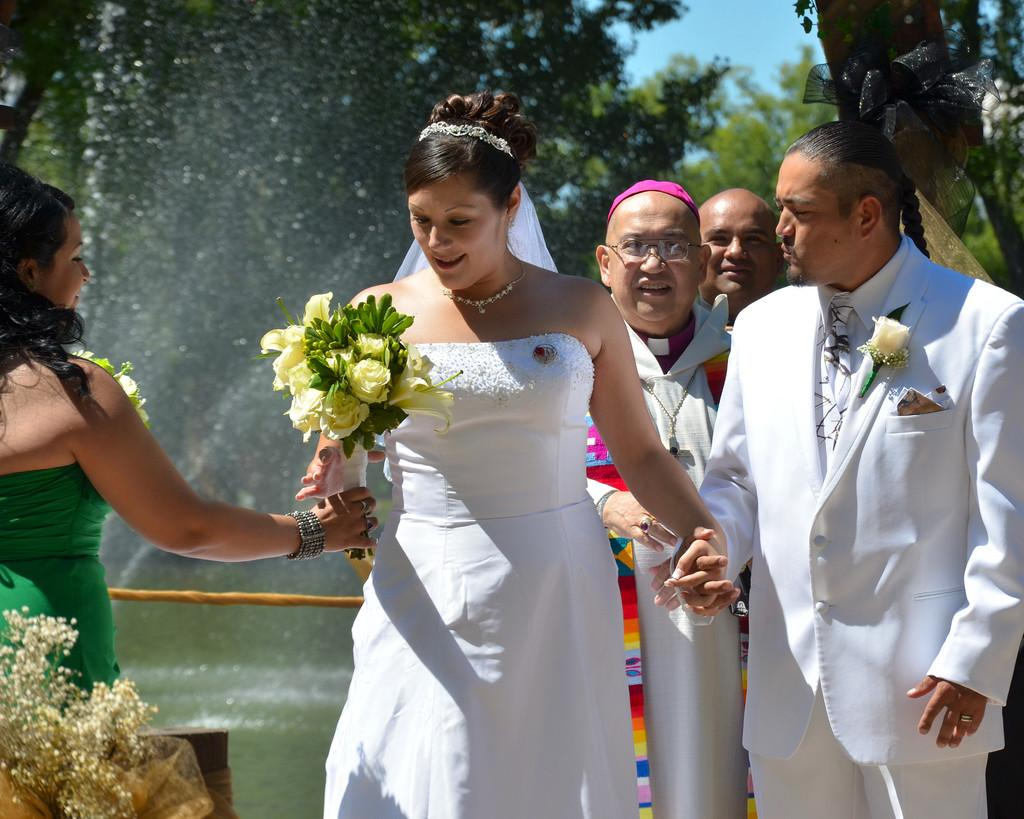What is the appearance of the woman in the image? There is a beautiful woman in the image. What is the woman wearing? The woman is wearing a white dress. Who else is present in the image? There is a man in the image. What is the man doing with the woman? The man is holding the woman's hand. What is the man wearing? The man is wearing a white dress. What can be seen in the background of the image? There is water visible in the image. What type of ship can be seen sailing in the water in the image? There is no ship visible in the image; it only features a woman and a man near water. 